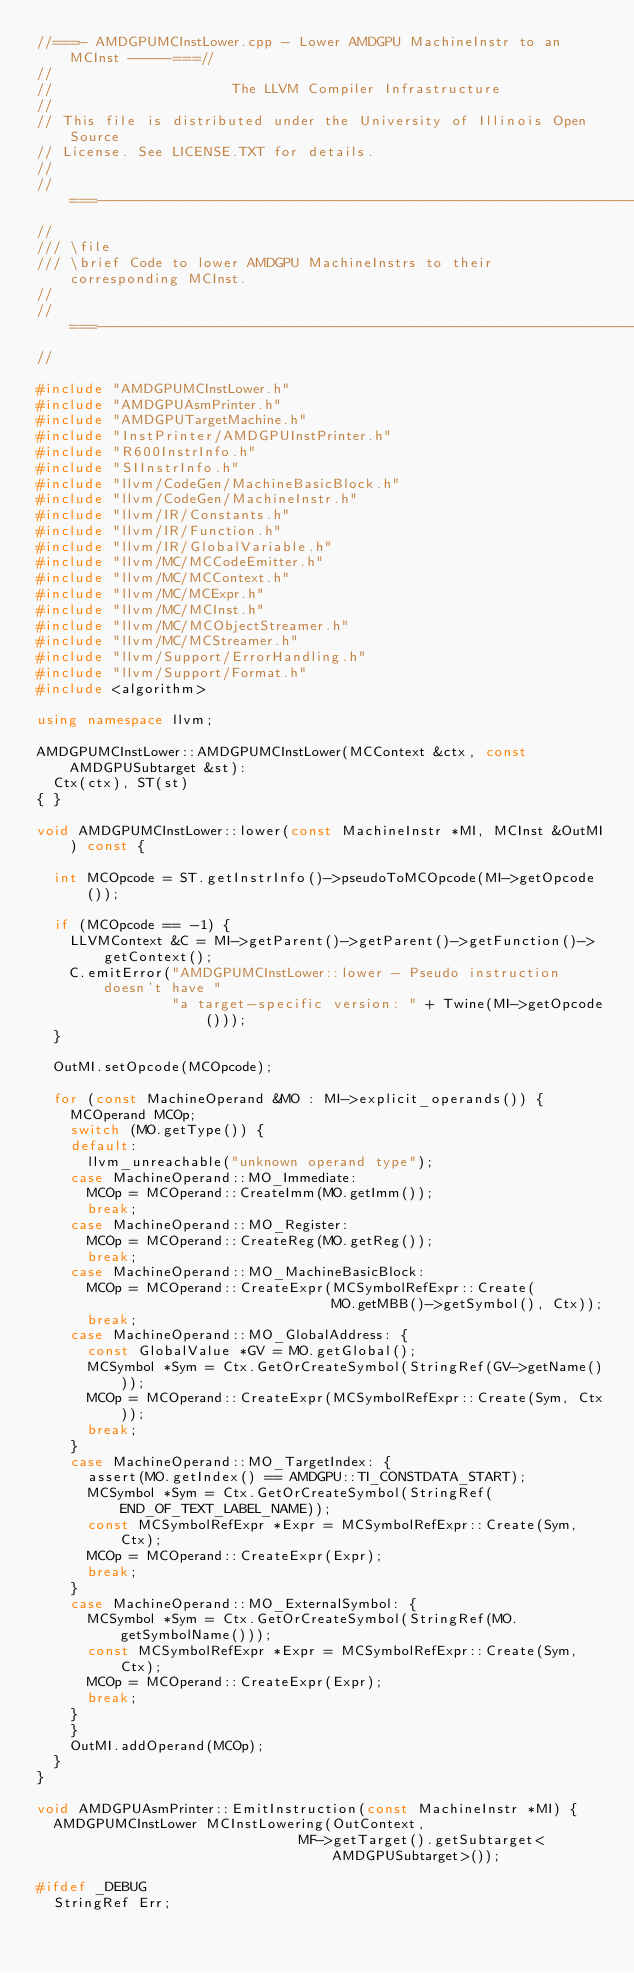Convert code to text. <code><loc_0><loc_0><loc_500><loc_500><_C++_>//===- AMDGPUMCInstLower.cpp - Lower AMDGPU MachineInstr to an MCInst -----===//
//
//                     The LLVM Compiler Infrastructure
//
// This file is distributed under the University of Illinois Open Source
// License. See LICENSE.TXT for details.
//
//===----------------------------------------------------------------------===//
//
/// \file
/// \brief Code to lower AMDGPU MachineInstrs to their corresponding MCInst.
//
//===----------------------------------------------------------------------===//
//

#include "AMDGPUMCInstLower.h"
#include "AMDGPUAsmPrinter.h"
#include "AMDGPUTargetMachine.h"
#include "InstPrinter/AMDGPUInstPrinter.h"
#include "R600InstrInfo.h"
#include "SIInstrInfo.h"
#include "llvm/CodeGen/MachineBasicBlock.h"
#include "llvm/CodeGen/MachineInstr.h"
#include "llvm/IR/Constants.h"
#include "llvm/IR/Function.h"
#include "llvm/IR/GlobalVariable.h"
#include "llvm/MC/MCCodeEmitter.h"
#include "llvm/MC/MCContext.h"
#include "llvm/MC/MCExpr.h"
#include "llvm/MC/MCInst.h"
#include "llvm/MC/MCObjectStreamer.h"
#include "llvm/MC/MCStreamer.h"
#include "llvm/Support/ErrorHandling.h"
#include "llvm/Support/Format.h"
#include <algorithm>

using namespace llvm;

AMDGPUMCInstLower::AMDGPUMCInstLower(MCContext &ctx, const AMDGPUSubtarget &st):
  Ctx(ctx), ST(st)
{ }

void AMDGPUMCInstLower::lower(const MachineInstr *MI, MCInst &OutMI) const {

  int MCOpcode = ST.getInstrInfo()->pseudoToMCOpcode(MI->getOpcode());

  if (MCOpcode == -1) {
    LLVMContext &C = MI->getParent()->getParent()->getFunction()->getContext();
    C.emitError("AMDGPUMCInstLower::lower - Pseudo instruction doesn't have "
                "a target-specific version: " + Twine(MI->getOpcode()));
  }

  OutMI.setOpcode(MCOpcode);

  for (const MachineOperand &MO : MI->explicit_operands()) {
    MCOperand MCOp;
    switch (MO.getType()) {
    default:
      llvm_unreachable("unknown operand type");
    case MachineOperand::MO_Immediate:
      MCOp = MCOperand::CreateImm(MO.getImm());
      break;
    case MachineOperand::MO_Register:
      MCOp = MCOperand::CreateReg(MO.getReg());
      break;
    case MachineOperand::MO_MachineBasicBlock:
      MCOp = MCOperand::CreateExpr(MCSymbolRefExpr::Create(
                                   MO.getMBB()->getSymbol(), Ctx));
      break;
    case MachineOperand::MO_GlobalAddress: {
      const GlobalValue *GV = MO.getGlobal();
      MCSymbol *Sym = Ctx.GetOrCreateSymbol(StringRef(GV->getName()));
      MCOp = MCOperand::CreateExpr(MCSymbolRefExpr::Create(Sym, Ctx));
      break;
    }
    case MachineOperand::MO_TargetIndex: {
      assert(MO.getIndex() == AMDGPU::TI_CONSTDATA_START);
      MCSymbol *Sym = Ctx.GetOrCreateSymbol(StringRef(END_OF_TEXT_LABEL_NAME));
      const MCSymbolRefExpr *Expr = MCSymbolRefExpr::Create(Sym, Ctx);
      MCOp = MCOperand::CreateExpr(Expr);
      break;
    }
    case MachineOperand::MO_ExternalSymbol: {
      MCSymbol *Sym = Ctx.GetOrCreateSymbol(StringRef(MO.getSymbolName()));
      const MCSymbolRefExpr *Expr = MCSymbolRefExpr::Create(Sym, Ctx);
      MCOp = MCOperand::CreateExpr(Expr);
      break;
    }
    }
    OutMI.addOperand(MCOp);
  }
}

void AMDGPUAsmPrinter::EmitInstruction(const MachineInstr *MI) {
  AMDGPUMCInstLower MCInstLowering(OutContext,
                               MF->getTarget().getSubtarget<AMDGPUSubtarget>());

#ifdef _DEBUG
  StringRef Err;</code> 